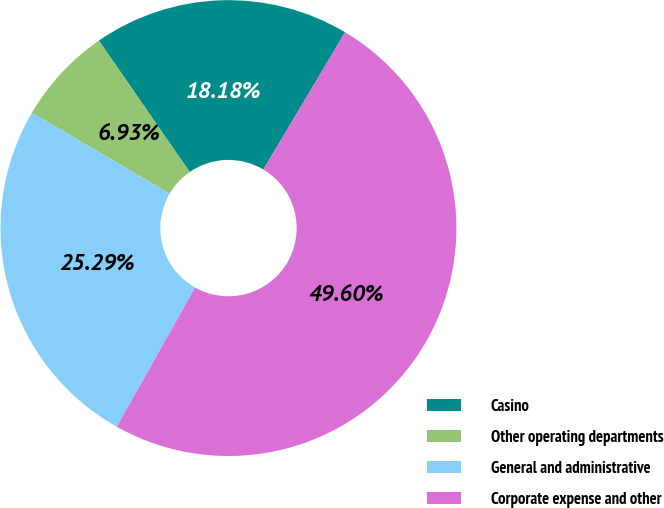Convert chart. <chart><loc_0><loc_0><loc_500><loc_500><pie_chart><fcel>Casino<fcel>Other operating departments<fcel>General and administrative<fcel>Corporate expense and other<nl><fcel>18.18%<fcel>6.93%<fcel>25.29%<fcel>49.6%<nl></chart> 